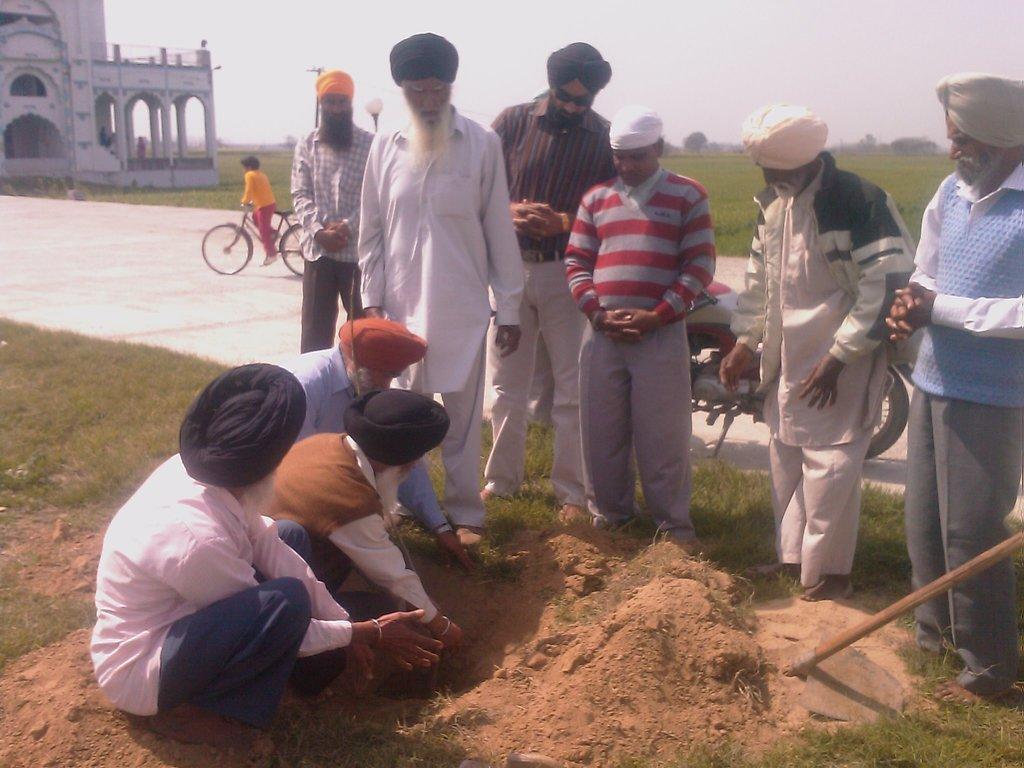Could you give a brief overview of what you see in this image? In this image I can see group of people. In front the person is wearing white color dress. In the background I can see few vehicles and I can also see the person riding the bi-cycle and I can also see the building in white color, trees in green color and the sky is in white color. 